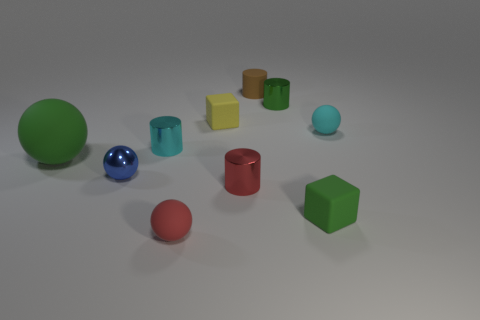Is there anything else that is the same size as the green ball?
Provide a succinct answer. No. What is the material of the tiny cylinder that is the same color as the big matte ball?
Offer a very short reply. Metal. What number of red metallic things are in front of the small green object that is in front of the tiny green cylinder?
Your answer should be very brief. 0. How many brown rubber things are there?
Ensure brevity in your answer.  1. Does the small yellow object have the same material as the tiny green object that is in front of the shiny sphere?
Make the answer very short. Yes. There is a block right of the brown object; is it the same color as the large matte sphere?
Offer a very short reply. Yes. There is a sphere that is both behind the small green rubber cube and in front of the large object; what material is it?
Your answer should be very brief. Metal. What is the size of the blue metallic sphere?
Your response must be concise. Small. Does the big thing have the same color as the matte cube that is in front of the green sphere?
Your response must be concise. Yes. What number of other things are the same color as the big matte thing?
Your answer should be very brief. 2. 